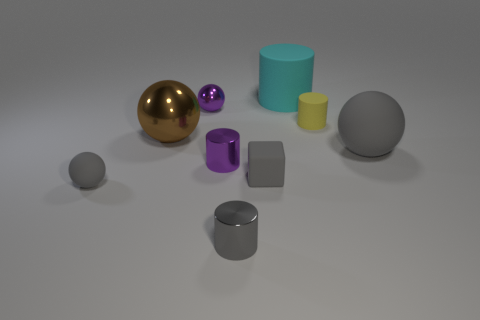What is the material of the big brown ball?
Ensure brevity in your answer.  Metal. The big matte object that is the same color as the tiny rubber sphere is what shape?
Your answer should be very brief. Sphere. Is the size of the purple shiny cylinder the same as the gray ball that is in front of the large matte ball?
Offer a terse response. Yes. There is a small object that is in front of the large brown sphere and on the left side of the tiny purple cylinder; what is its color?
Your answer should be compact. Gray. How many objects are either rubber objects left of the big gray thing or gray matte balls that are on the left side of the big gray rubber thing?
Your answer should be very brief. 4. What is the color of the matte sphere right of the small sphere behind the rubber sphere that is on the left side of the big shiny ball?
Make the answer very short. Gray. Is there a gray shiny object of the same shape as the yellow object?
Provide a short and direct response. Yes. What number of gray rubber balls are there?
Make the answer very short. 2. What is the shape of the big gray matte object?
Give a very brief answer. Sphere. How many gray objects are the same size as the cyan object?
Give a very brief answer. 1. 